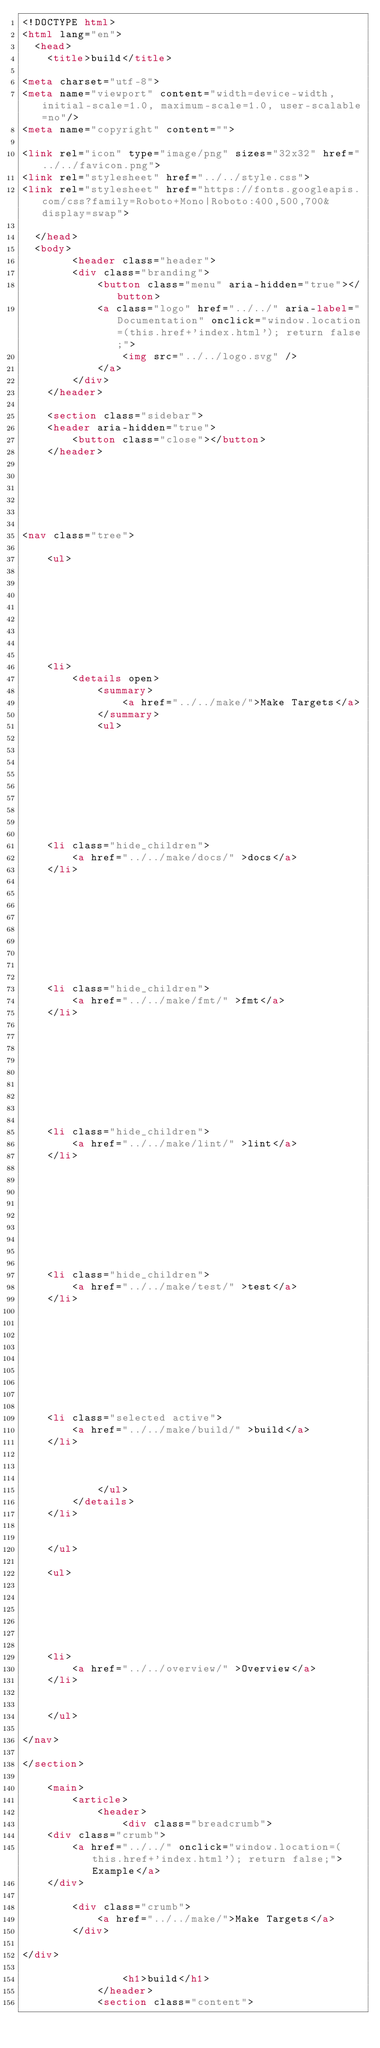<code> <loc_0><loc_0><loc_500><loc_500><_HTML_><!DOCTYPE html>
<html lang="en">
  <head>
    <title>build</title>

<meta charset="utf-8">
<meta name="viewport" content="width=device-width, initial-scale=1.0, maximum-scale=1.0, user-scalable=no"/>
<meta name="copyright" content="">

<link rel="icon" type="image/png" sizes="32x32" href="../../favicon.png">
<link rel="stylesheet" href="../../style.css">
<link rel="stylesheet" href="https://fonts.googleapis.com/css?family=Roboto+Mono|Roboto:400,500,700&display=swap">

  </head>
  <body>
        <header class="header">
        <div class="branding">
            <button class="menu" aria-hidden="true"></button>
            <a class="logo" href="../../" aria-label="Documentation" onclick="window.location=(this.href+'index.html'); return false;">
                <img src="../../logo.svg" />
            </a>
        </div>
    </header>

    <section class="sidebar">
    <header aria-hidden="true">
        <button class="close"></button>
    </header>
    





<nav class="tree">

    <ul>
    
    

    

    

    
    <li>
        <details open>
            <summary>
                <a href="../../make/">Make Targets</a>
            </summary>
            <ul>
            

            
            
    

    

    
    <li class="hide_children">
        <a href="../../make/docs/" >docs</a>
    </li>
    

            
            
    

    

    
    <li class="hide_children">
        <a href="../../make/fmt/" >fmt</a>
    </li>
    

            
            
    

    

    
    <li class="hide_children">
        <a href="../../make/lint/" >lint</a>
    </li>
    

            
            
    

    

    
    <li class="hide_children">
        <a href="../../make/test/" >test</a>
    </li>
    

            
            
    

    

    
    <li class="selected active">
        <a href="../../make/build/" >build</a>
    </li>
    

            
            </ul>
        </details>
    </li>
    

    </ul>
    
    <ul>
    
    

    

    
    <li>
        <a href="../../overview/" >Overview</a>
    </li>
    

    </ul>
    
</nav>

</section>

    <main>
        <article>
            <header>
                <div class="breadcrumb">
    <div class="crumb">
        <a href="../../" onclick="window.location=(this.href+'index.html'); return false;">Example</a>
    </div>
    
        <div class="crumb">
            <a href="../../make/">Make Targets</a>
        </div>
        
</div>

                <h1>build</h1>
            </header>
            <section class="content"></code> 